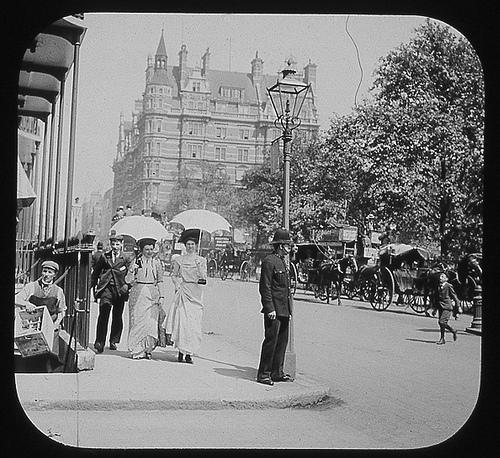Question: what are they carrying?
Choices:
A. Boxes.
B. Bags.
C. Children.
D. Umbrellas.
Answer with the letter. Answer: D Question: what is black?
Choices:
A. Car.
B. Cell phone.
C. Suit.
D. Coat.
Answer with the letter. Answer: C Question: how many umbrellas?
Choices:
A. Two.
B. Three.
C. Four.
D. Five.
Answer with the letter. Answer: A Question: who is standing?
Choices:
A. Woman.
B. Children.
C. Man.
D. Dog.
Answer with the letter. Answer: C 